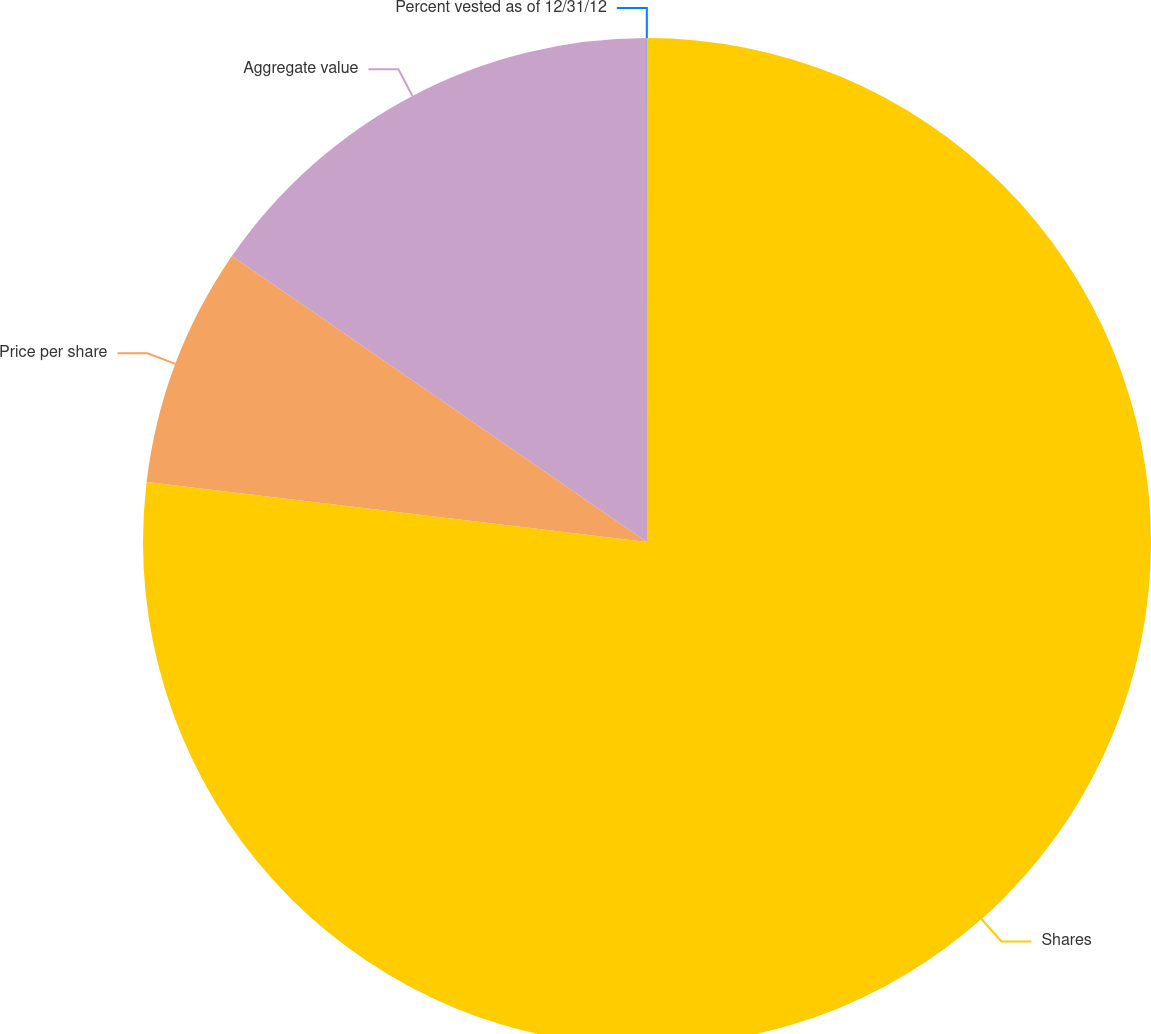<chart> <loc_0><loc_0><loc_500><loc_500><pie_chart><fcel>Shares<fcel>Price per share<fcel>Aggregate value<fcel>Percent vested as of 12/31/12<nl><fcel>76.9%<fcel>7.7%<fcel>15.39%<fcel>0.01%<nl></chart> 